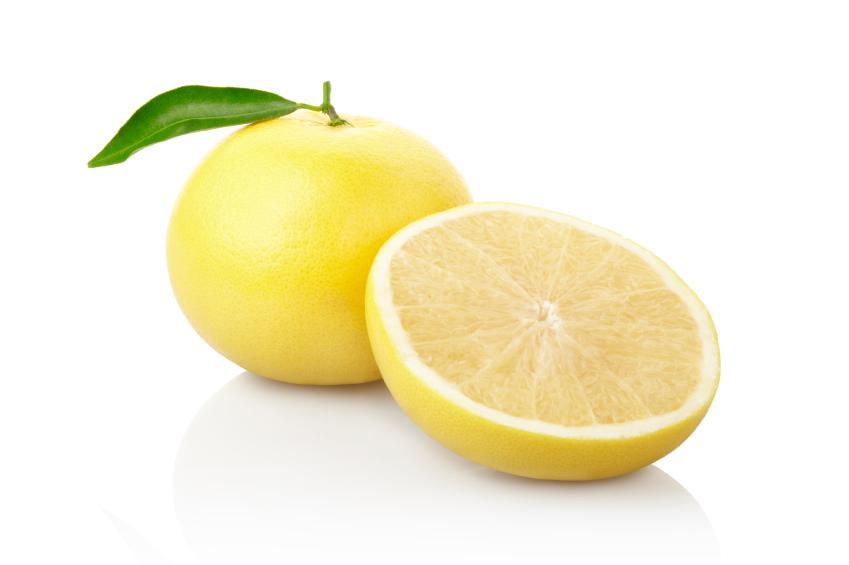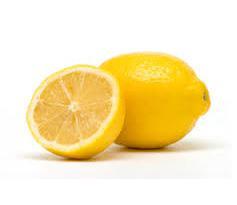The first image is the image on the left, the second image is the image on the right. Analyze the images presented: Is the assertion "Both images contain cut lemons." valid? Answer yes or no. Yes. 